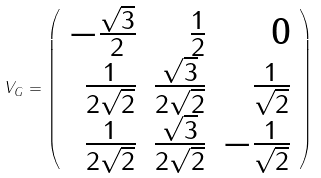Convert formula to latex. <formula><loc_0><loc_0><loc_500><loc_500>V _ { G } = \left ( \begin{array} { r r r } - { \frac { \sqrt { 3 } } { 2 } } & { \frac { 1 } { 2 } } & 0 \\ { \frac { 1 } { 2 \sqrt { 2 } } } & \frac { \sqrt { 3 } } { 2 \sqrt { 2 } } & { \frac { 1 } { \sqrt { 2 } } } \\ { \frac { 1 } { 2 \sqrt { 2 } } } & \frac { \sqrt { 3 } } { 2 \sqrt { 2 } } & { - \frac { 1 } { \sqrt { 2 } } } \end{array} \right )</formula> 